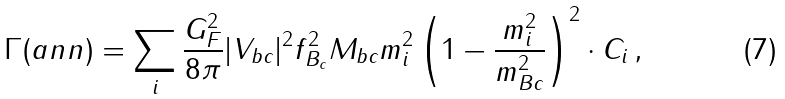<formula> <loc_0><loc_0><loc_500><loc_500>\Gamma ( a n n ) = \sum _ { i } \frac { G ^ { 2 } _ { F } } { 8 \pi } | V _ { b c } | ^ { 2 } f ^ { 2 } _ { B _ { c } } M _ { b c } m ^ { 2 } _ { i } \left ( 1 - \frac { m ^ { 2 } _ { i } } { m ^ { 2 } _ { B c } } \right ) ^ { 2 } \cdot C _ { i } \, ,</formula> 